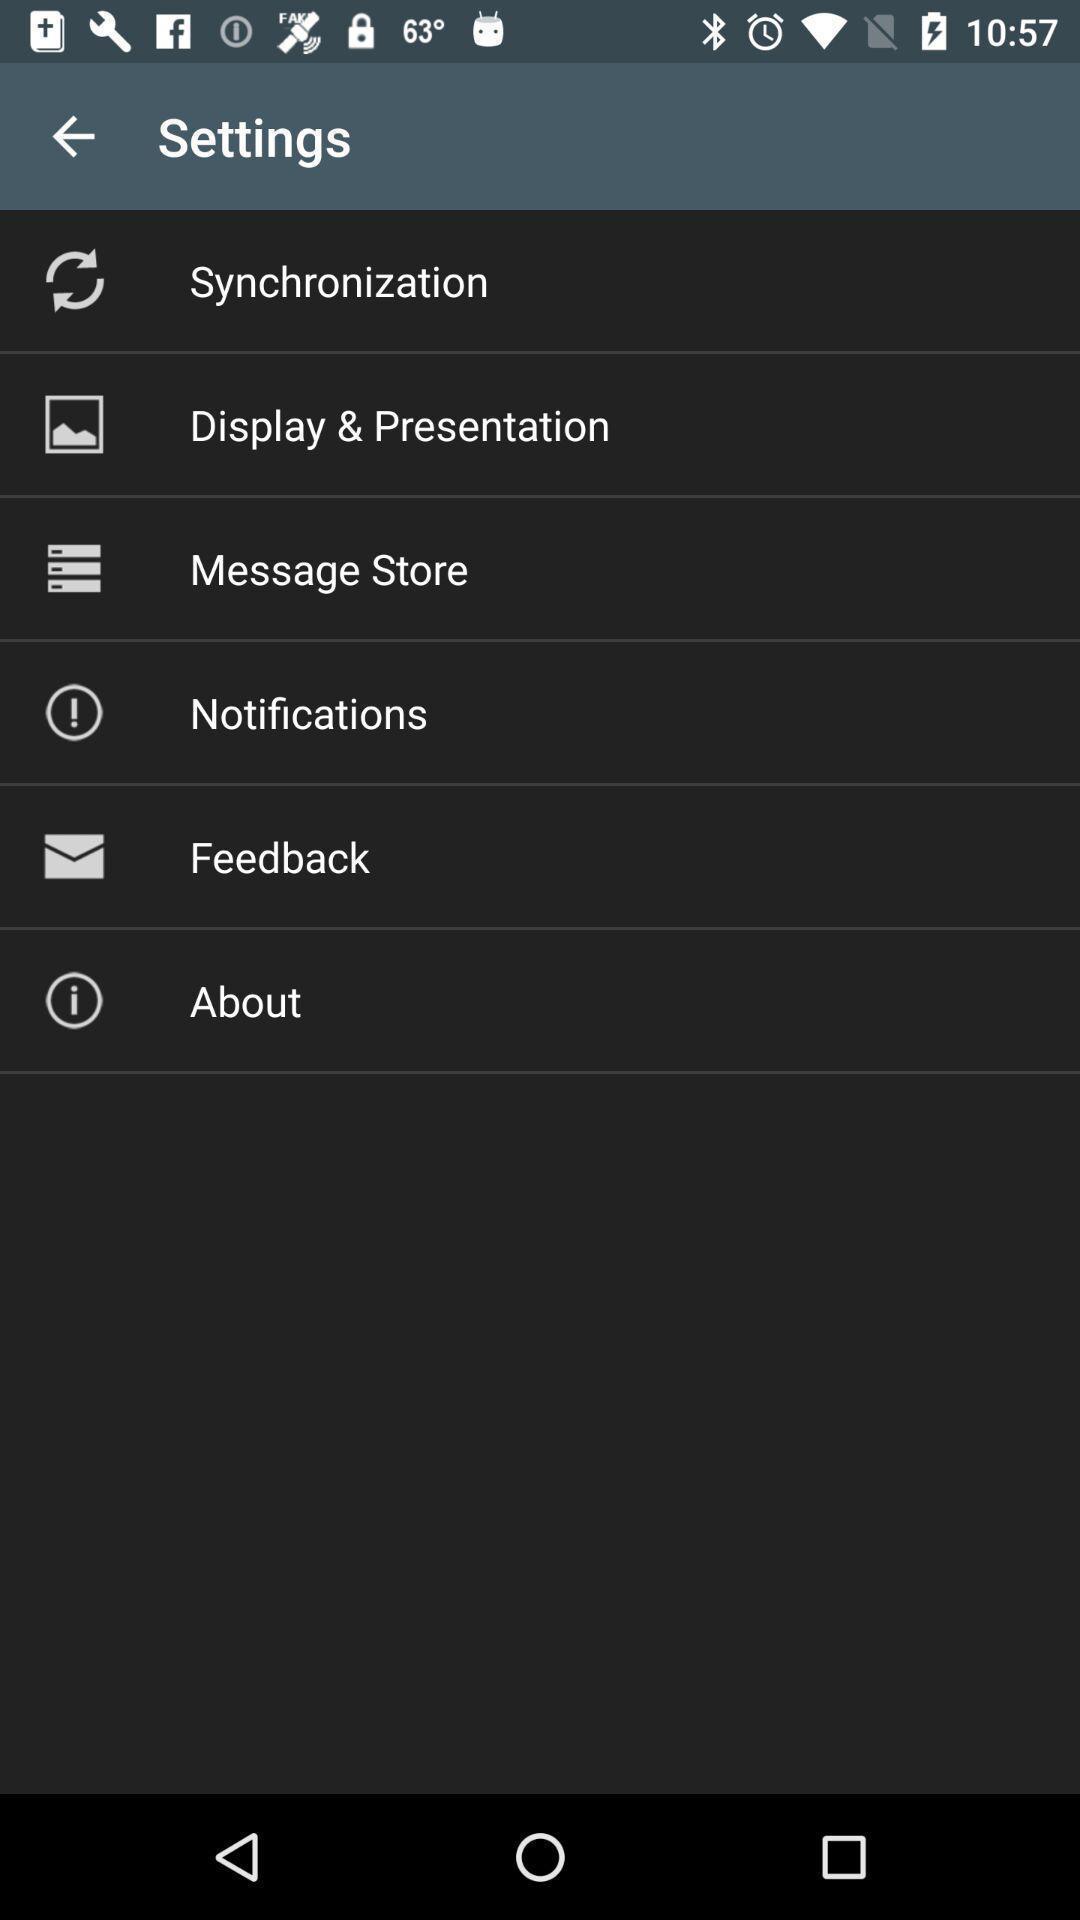Describe this image in words. Settings page with various other options. 